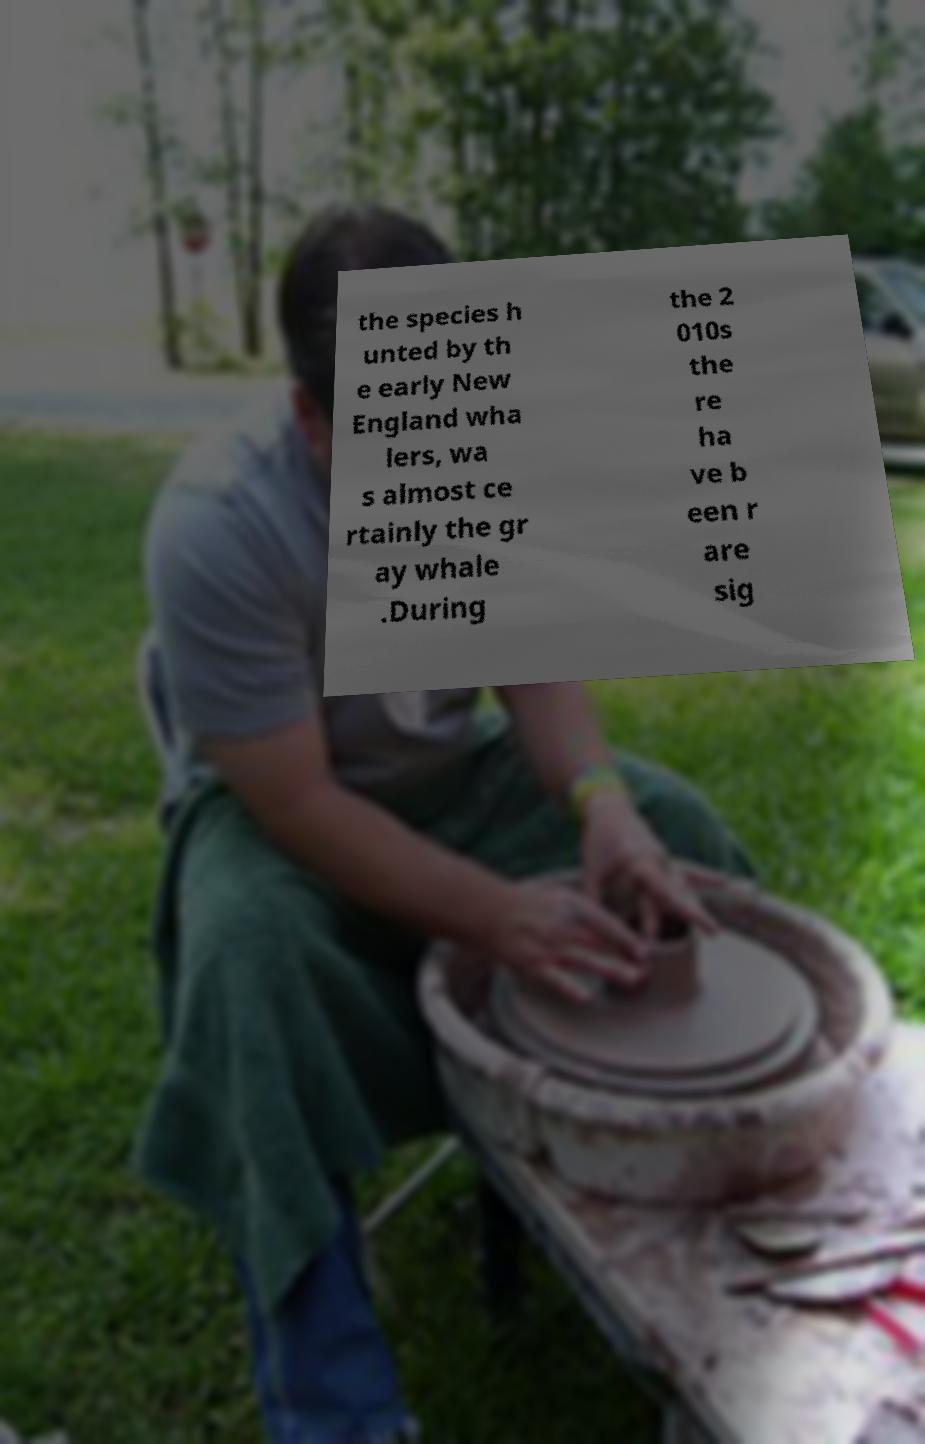Could you assist in decoding the text presented in this image and type it out clearly? the species h unted by th e early New England wha lers, wa s almost ce rtainly the gr ay whale .During the 2 010s the re ha ve b een r are sig 